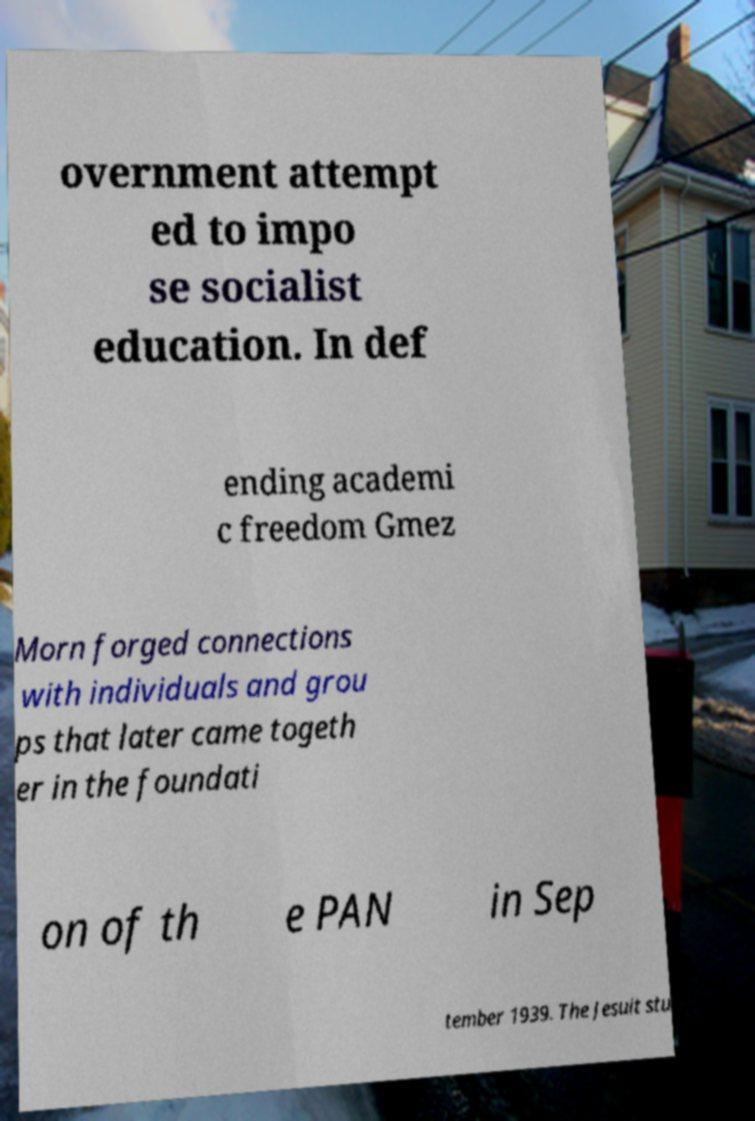Please identify and transcribe the text found in this image. overnment attempt ed to impo se socialist education. In def ending academi c freedom Gmez Morn forged connections with individuals and grou ps that later came togeth er in the foundati on of th e PAN in Sep tember 1939. The Jesuit stu 